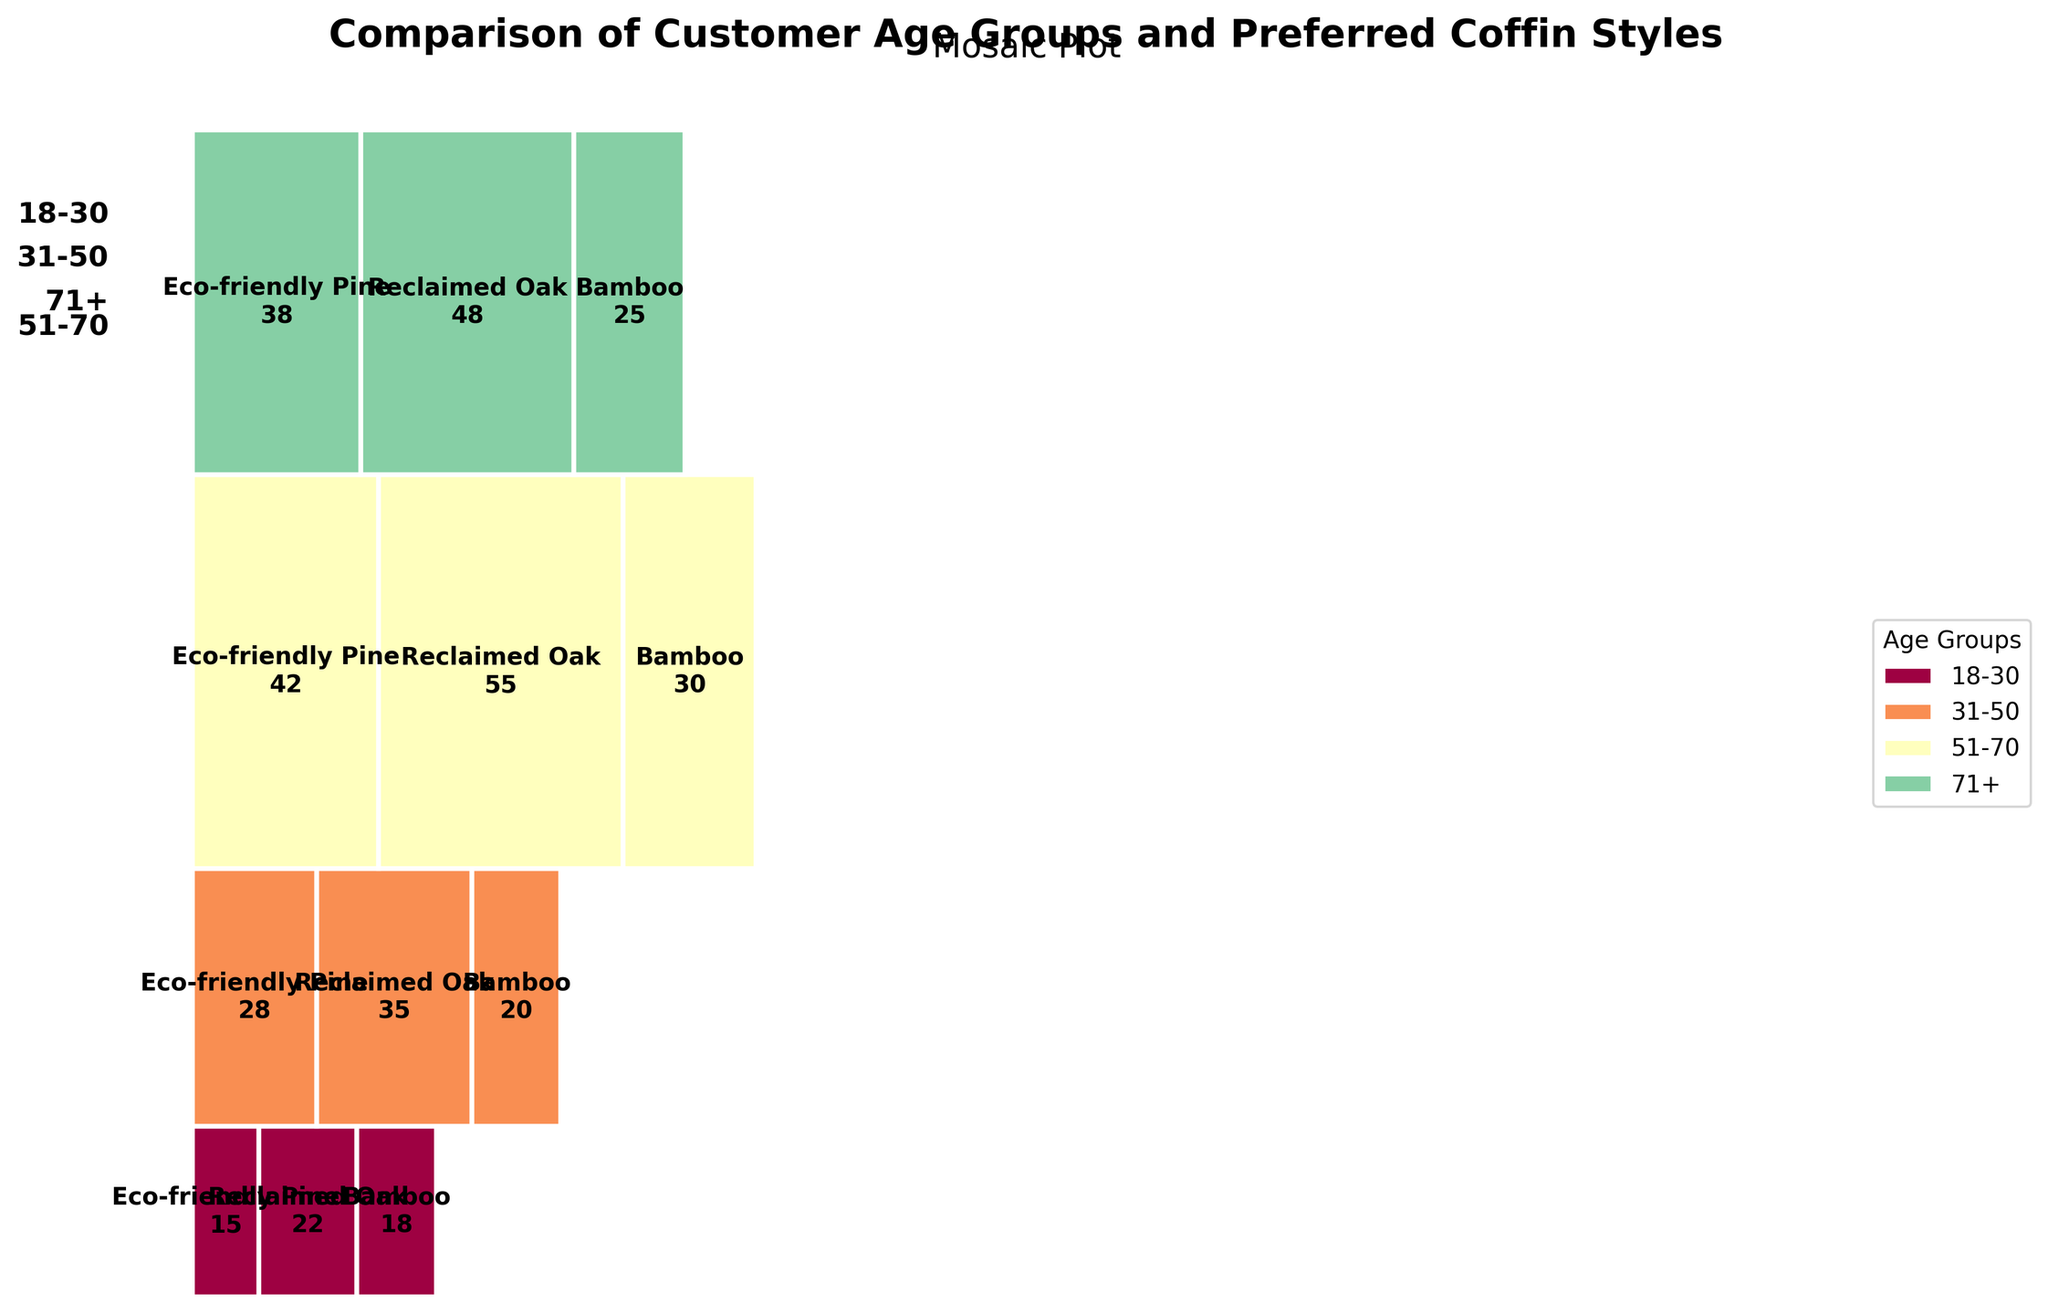What is the title of the figure? The title of the figure is usually placed at the top and summarizes what the figure is about. In this case, it's a visual comparison of age groups and their preferred coffin styles.
Answer: "Comparison of Customer Age Groups and Preferred Coffin Styles" Which coffin style is preferred the most by the 31-50 age group? To determine this, we need to look at the size of each segment for the 31-50 age group. The style with the largest segment is the most preferred.
Answer: Reclaimed Oak What age group has the highest proportion of customers preferring Reclaimed Oak? Examine the segments corresponding to Reclaimed Oak for each age group and identify the largest one. This indicates the age group with the highest proportion preferring Reclaimed Oak.
Answer: 51-70 How many Eco-friendly Pine coffins were preferred by the 18-30 age group? Look at the segment labeled "Eco-friendly Pine" within the 18-30 age group segment and note the count mentioned within it.
Answer: 15 Which combination of age group and coffin style has the smallest count? Identify the segment with the smallest area and check the labels to determine the relevant age group and coffin style.
Answer: Eco-friendly Pine, 18-30 Compare the popularity of Bamboo coffins between the 51-70 and 71+ age groups. Which age group prefers Bamboo more? Examine and compare the segments labeled "Bamboo" for the 51-70 and 71+ age groups; the larger one indicates the more preferred age group.
Answer: 51-70 How does the proportion of Eco-friendly Pine coffins vary between the 31-50 and 51-70 age groups? Compare the segment sizes labeled "Eco-friendly Pine" within the 31-50 and 51-70 age groups to see if one is noticeably larger or smaller than the other.
Answer: Larger in 51-70 Which coffin style is least preferred by the 71+ age group? Look at the size of the segments for each coffin style within the 71+ age group; the smallest segment represents the least preferred style.
Answer: Bamboo 